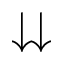<formula> <loc_0><loc_0><loc_500><loc_500>\downdownarrows</formula> 